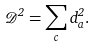<formula> <loc_0><loc_0><loc_500><loc_500>\mathcal { D } ^ { 2 } = \sum _ { c } d _ { a } ^ { 2 } .</formula> 